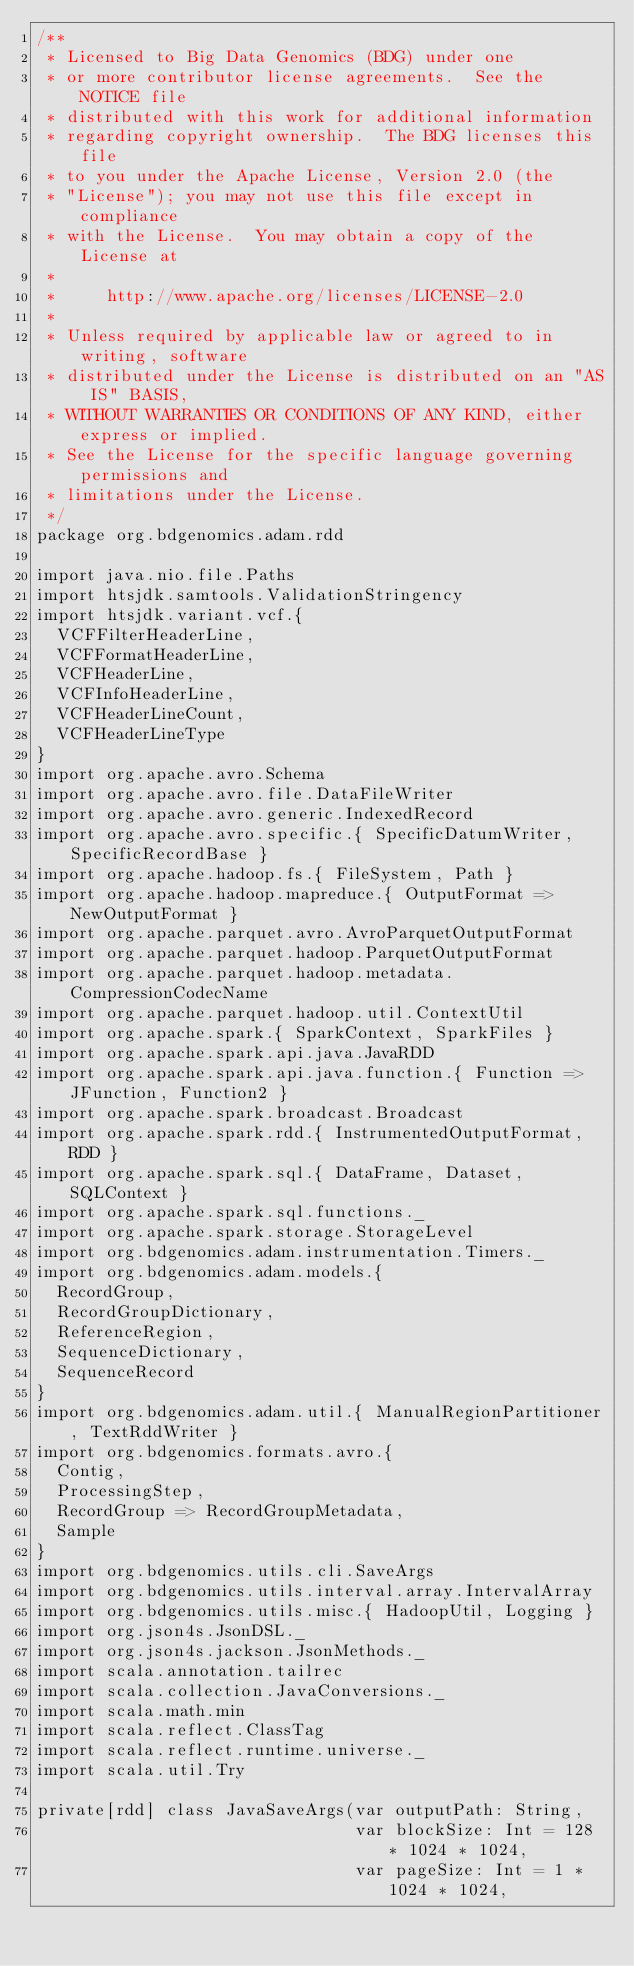Convert code to text. <code><loc_0><loc_0><loc_500><loc_500><_Scala_>/**
 * Licensed to Big Data Genomics (BDG) under one
 * or more contributor license agreements.  See the NOTICE file
 * distributed with this work for additional information
 * regarding copyright ownership.  The BDG licenses this file
 * to you under the Apache License, Version 2.0 (the
 * "License"); you may not use this file except in compliance
 * with the License.  You may obtain a copy of the License at
 *
 *     http://www.apache.org/licenses/LICENSE-2.0
 *
 * Unless required by applicable law or agreed to in writing, software
 * distributed under the License is distributed on an "AS IS" BASIS,
 * WITHOUT WARRANTIES OR CONDITIONS OF ANY KIND, either express or implied.
 * See the License for the specific language governing permissions and
 * limitations under the License.
 */
package org.bdgenomics.adam.rdd

import java.nio.file.Paths
import htsjdk.samtools.ValidationStringency
import htsjdk.variant.vcf.{
  VCFFilterHeaderLine,
  VCFFormatHeaderLine,
  VCFHeaderLine,
  VCFInfoHeaderLine,
  VCFHeaderLineCount,
  VCFHeaderLineType
}
import org.apache.avro.Schema
import org.apache.avro.file.DataFileWriter
import org.apache.avro.generic.IndexedRecord
import org.apache.avro.specific.{ SpecificDatumWriter, SpecificRecordBase }
import org.apache.hadoop.fs.{ FileSystem, Path }
import org.apache.hadoop.mapreduce.{ OutputFormat => NewOutputFormat }
import org.apache.parquet.avro.AvroParquetOutputFormat
import org.apache.parquet.hadoop.ParquetOutputFormat
import org.apache.parquet.hadoop.metadata.CompressionCodecName
import org.apache.parquet.hadoop.util.ContextUtil
import org.apache.spark.{ SparkContext, SparkFiles }
import org.apache.spark.api.java.JavaRDD
import org.apache.spark.api.java.function.{ Function => JFunction, Function2 }
import org.apache.spark.broadcast.Broadcast
import org.apache.spark.rdd.{ InstrumentedOutputFormat, RDD }
import org.apache.spark.sql.{ DataFrame, Dataset, SQLContext }
import org.apache.spark.sql.functions._
import org.apache.spark.storage.StorageLevel
import org.bdgenomics.adam.instrumentation.Timers._
import org.bdgenomics.adam.models.{
  RecordGroup,
  RecordGroupDictionary,
  ReferenceRegion,
  SequenceDictionary,
  SequenceRecord
}
import org.bdgenomics.adam.util.{ ManualRegionPartitioner, TextRddWriter }
import org.bdgenomics.formats.avro.{
  Contig,
  ProcessingStep,
  RecordGroup => RecordGroupMetadata,
  Sample
}
import org.bdgenomics.utils.cli.SaveArgs
import org.bdgenomics.utils.interval.array.IntervalArray
import org.bdgenomics.utils.misc.{ HadoopUtil, Logging }
import org.json4s.JsonDSL._
import org.json4s.jackson.JsonMethods._
import scala.annotation.tailrec
import scala.collection.JavaConversions._
import scala.math.min
import scala.reflect.ClassTag
import scala.reflect.runtime.universe._
import scala.util.Try

private[rdd] class JavaSaveArgs(var outputPath: String,
                                var blockSize: Int = 128 * 1024 * 1024,
                                var pageSize: Int = 1 * 1024 * 1024,</code> 